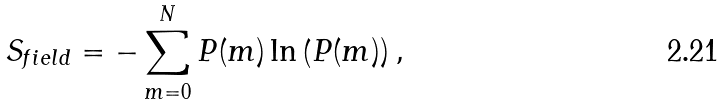Convert formula to latex. <formula><loc_0><loc_0><loc_500><loc_500>S _ { f i e l d } = - \sum _ { m = 0 } ^ { N } P ( m ) \ln \left ( P ( m ) \right ) ,</formula> 